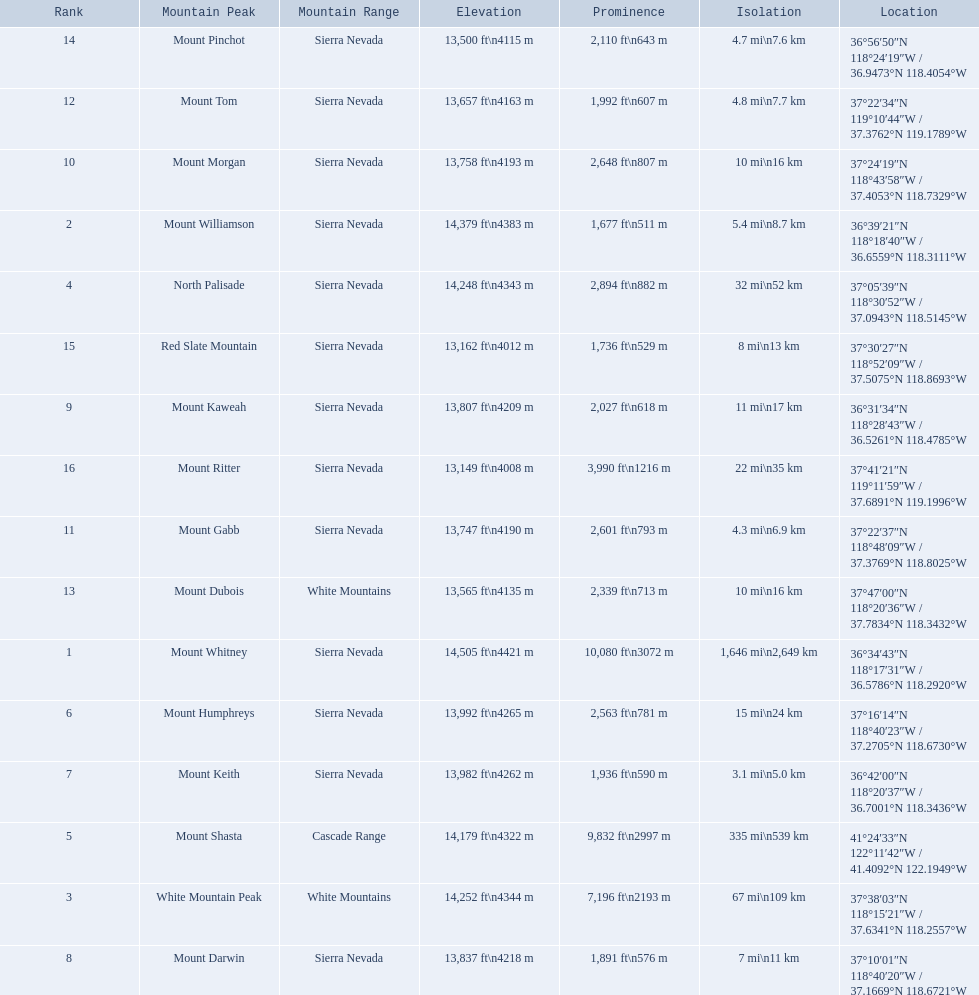What are the heights of the californian mountain peaks? 14,505 ft\n4421 m, 14,379 ft\n4383 m, 14,252 ft\n4344 m, 14,248 ft\n4343 m, 14,179 ft\n4322 m, 13,992 ft\n4265 m, 13,982 ft\n4262 m, 13,837 ft\n4218 m, 13,807 ft\n4209 m, 13,758 ft\n4193 m, 13,747 ft\n4190 m, 13,657 ft\n4163 m, 13,565 ft\n4135 m, 13,500 ft\n4115 m, 13,162 ft\n4012 m, 13,149 ft\n4008 m. What elevation is 13,149 ft or less? 13,149 ft\n4008 m. What mountain peak is at this elevation? Mount Ritter. 